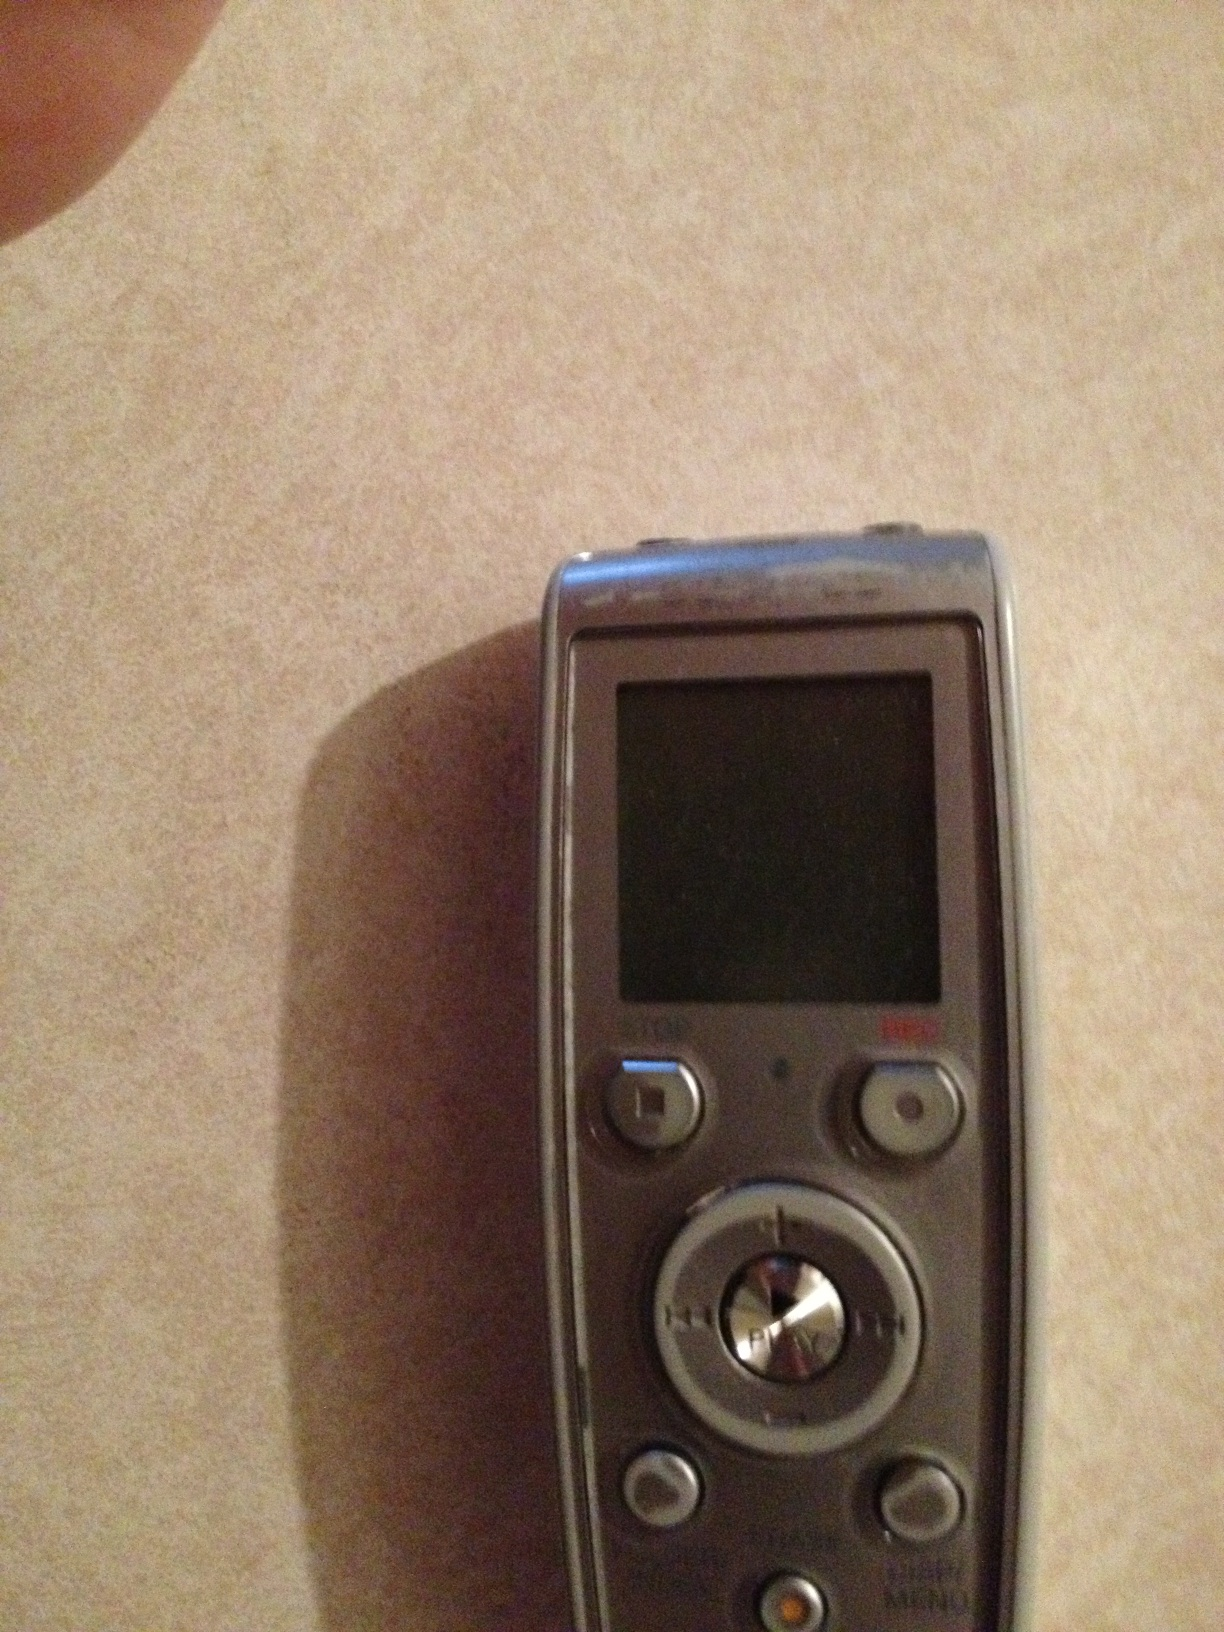How can this device be used in an educational setting? In an educational setting, this digital voice recorder is excellent for capturing lectures, discussions, or study group conversations. Students can use it to review and transcribe lectures for better understanding and note-taking. Teachers might record their lectures and share them with students who need to revisit the material for study or review purposes. What are the audio storage capabilities of this device likely to be? This device is likely to have a certain amount of internal storage, perhaps capable of holding several hours of recorded audio. Additionally, some recorders allow for external memory cards, significantly expanding the storage capacity and allowing users to organize recordings more effectively. 